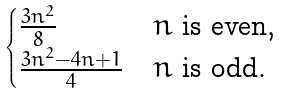<formula> <loc_0><loc_0><loc_500><loc_500>\begin{cases} \frac { 3 n ^ { 2 } } { 8 } & \text {$n$ is even,} \\ \frac { 3 n ^ { 2 } - 4 n + 1 } { 4 } & \text {$n$ is odd.} \end{cases}</formula> 